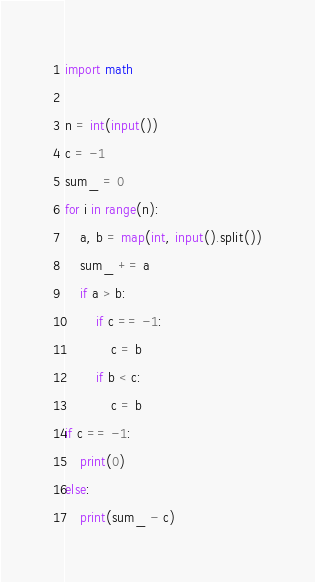Convert code to text. <code><loc_0><loc_0><loc_500><loc_500><_Python_>import math

n = int(input())
c = -1
sum_ = 0
for i in range(n):
    a, b = map(int, input().split())
    sum_ += a
    if a > b:
        if c == -1:
            c = b
        if b < c:
            c = b
if c == -1:
    print(0)
else:
    print(sum_ - c)
</code> 